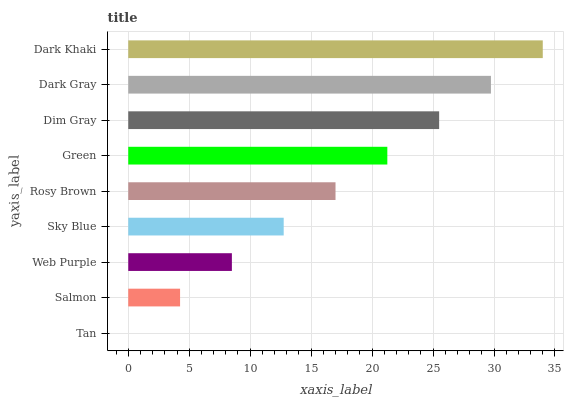Is Tan the minimum?
Answer yes or no. Yes. Is Dark Khaki the maximum?
Answer yes or no. Yes. Is Salmon the minimum?
Answer yes or no. No. Is Salmon the maximum?
Answer yes or no. No. Is Salmon greater than Tan?
Answer yes or no. Yes. Is Tan less than Salmon?
Answer yes or no. Yes. Is Tan greater than Salmon?
Answer yes or no. No. Is Salmon less than Tan?
Answer yes or no. No. Is Rosy Brown the high median?
Answer yes or no. Yes. Is Rosy Brown the low median?
Answer yes or no. Yes. Is Salmon the high median?
Answer yes or no. No. Is Green the low median?
Answer yes or no. No. 